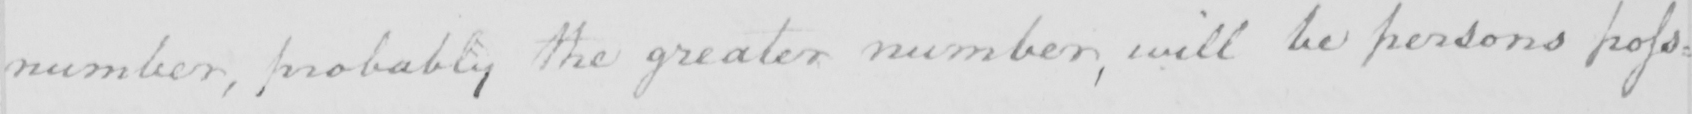What text is written in this handwritten line? number , probably the greater number , will be persons poss : 